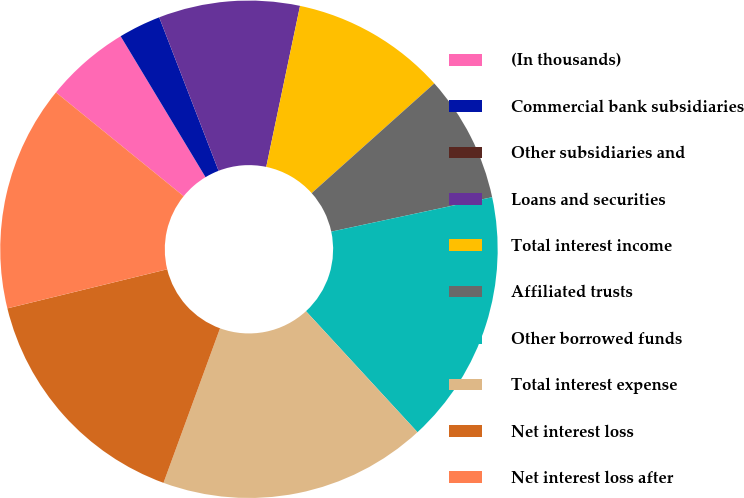Convert chart. <chart><loc_0><loc_0><loc_500><loc_500><pie_chart><fcel>(In thousands)<fcel>Commercial bank subsidiaries<fcel>Other subsidiaries and<fcel>Loans and securities<fcel>Total interest income<fcel>Affiliated trusts<fcel>Other borrowed funds<fcel>Total interest expense<fcel>Net interest loss<fcel>Net interest loss after<nl><fcel>5.51%<fcel>2.75%<fcel>0.0%<fcel>9.17%<fcel>10.09%<fcel>8.26%<fcel>16.51%<fcel>17.43%<fcel>15.6%<fcel>14.68%<nl></chart> 